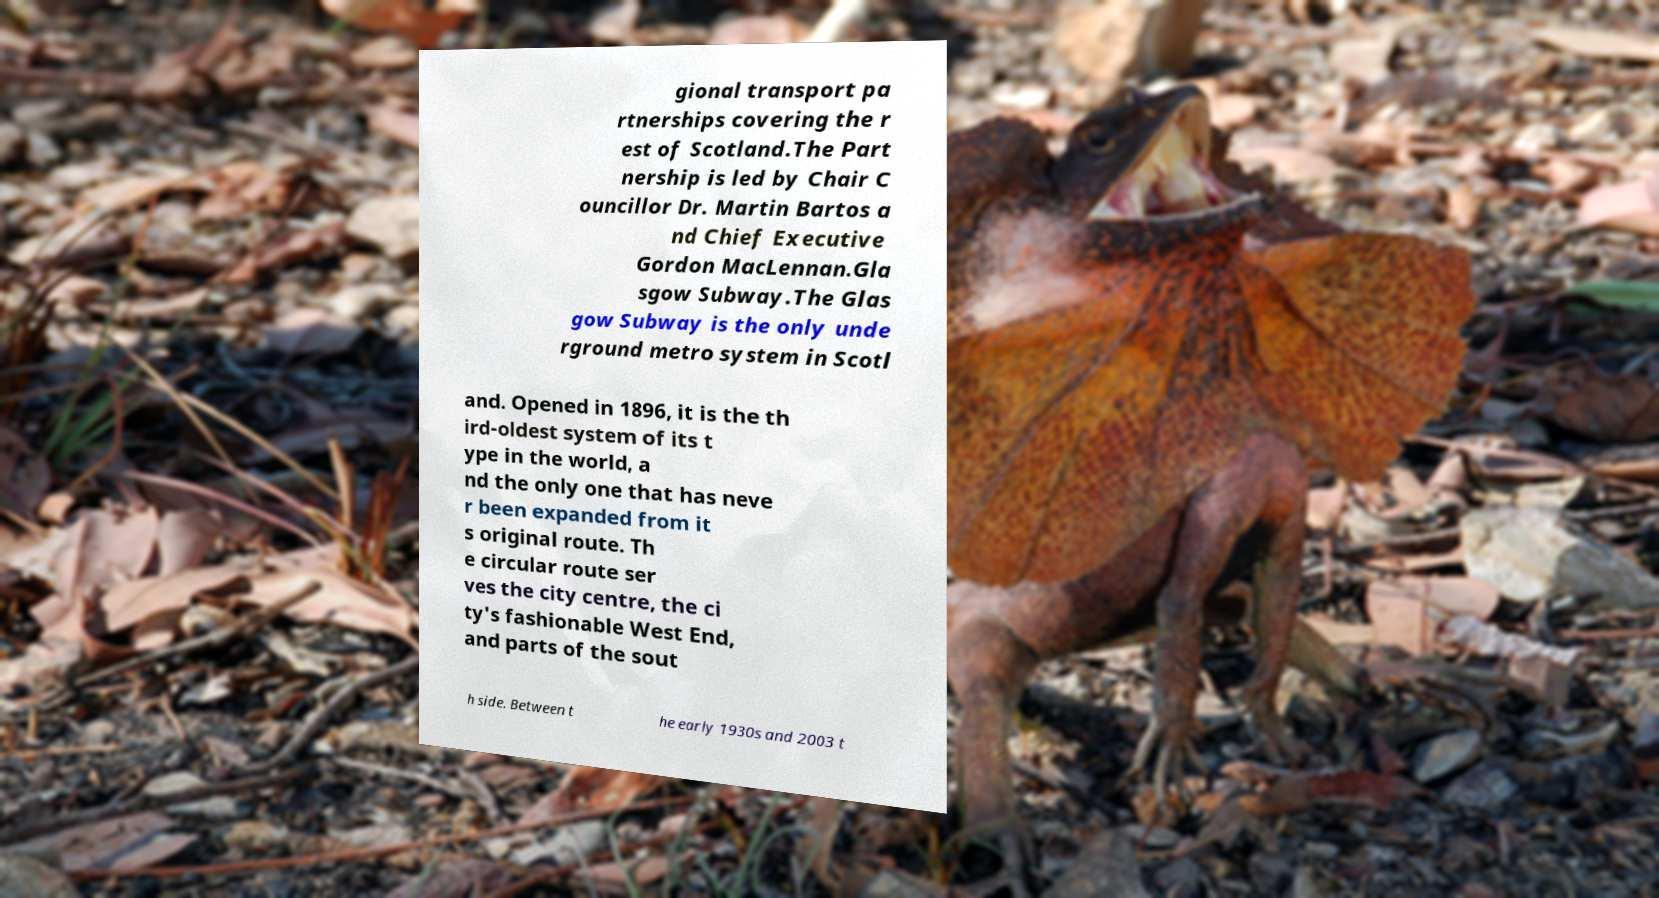I need the written content from this picture converted into text. Can you do that? gional transport pa rtnerships covering the r est of Scotland.The Part nership is led by Chair C ouncillor Dr. Martin Bartos a nd Chief Executive Gordon MacLennan.Gla sgow Subway.The Glas gow Subway is the only unde rground metro system in Scotl and. Opened in 1896, it is the th ird-oldest system of its t ype in the world, a nd the only one that has neve r been expanded from it s original route. Th e circular route ser ves the city centre, the ci ty's fashionable West End, and parts of the sout h side. Between t he early 1930s and 2003 t 